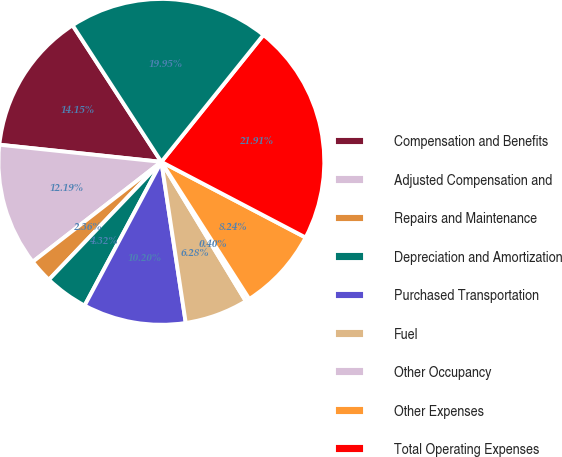Convert chart. <chart><loc_0><loc_0><loc_500><loc_500><pie_chart><fcel>Compensation and Benefits<fcel>Adjusted Compensation and<fcel>Repairs and Maintenance<fcel>Depreciation and Amortization<fcel>Purchased Transportation<fcel>Fuel<fcel>Other Occupancy<fcel>Other Expenses<fcel>Total Operating Expenses<fcel>Adjusted Total Operating<nl><fcel>14.15%<fcel>12.19%<fcel>2.36%<fcel>4.32%<fcel>10.2%<fcel>6.28%<fcel>0.4%<fcel>8.24%<fcel>21.91%<fcel>19.95%<nl></chart> 